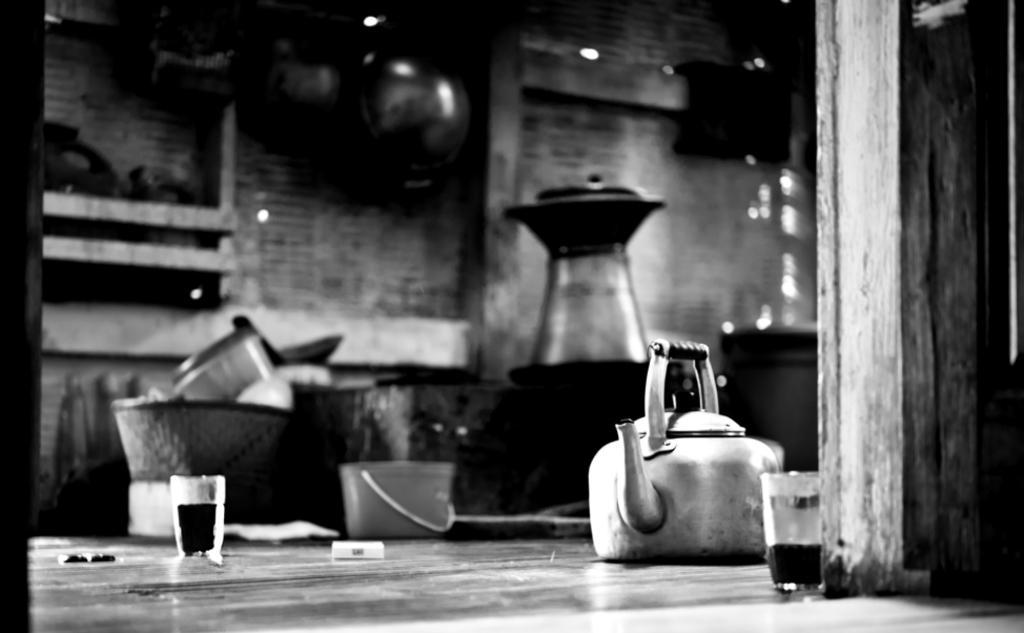What is the color scheme of the image? The image is black and white. What object can be seen on the floor in the image? There is a kettle on the floor. What else is on the floor besides the kettle? There are glasses with liquid on the floor. What type of oil can be seen dripping from the kettle in the image? There is no oil present in the image, and the kettle is not shown dripping anything. 